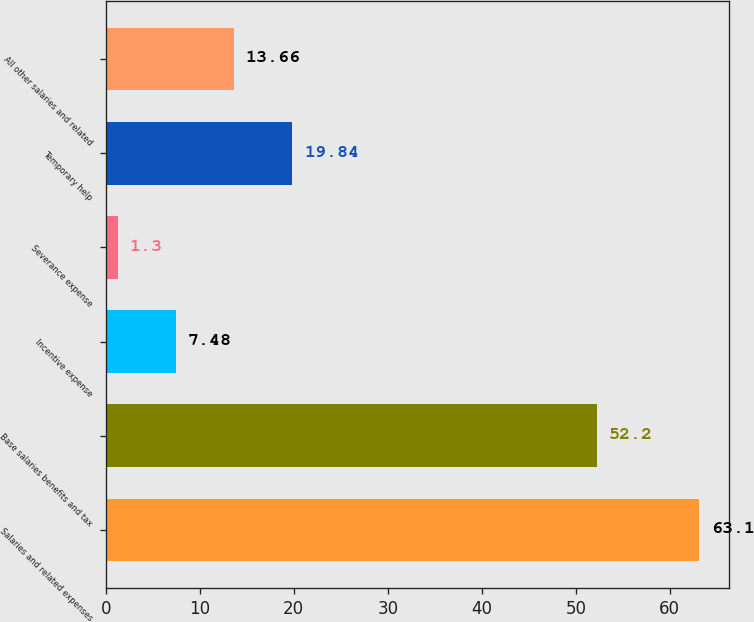Convert chart to OTSL. <chart><loc_0><loc_0><loc_500><loc_500><bar_chart><fcel>Salaries and related expenses<fcel>Base salaries benefits and tax<fcel>Incentive expense<fcel>Severance expense<fcel>Temporary help<fcel>All other salaries and related<nl><fcel>63.1<fcel>52.2<fcel>7.48<fcel>1.3<fcel>19.84<fcel>13.66<nl></chart> 